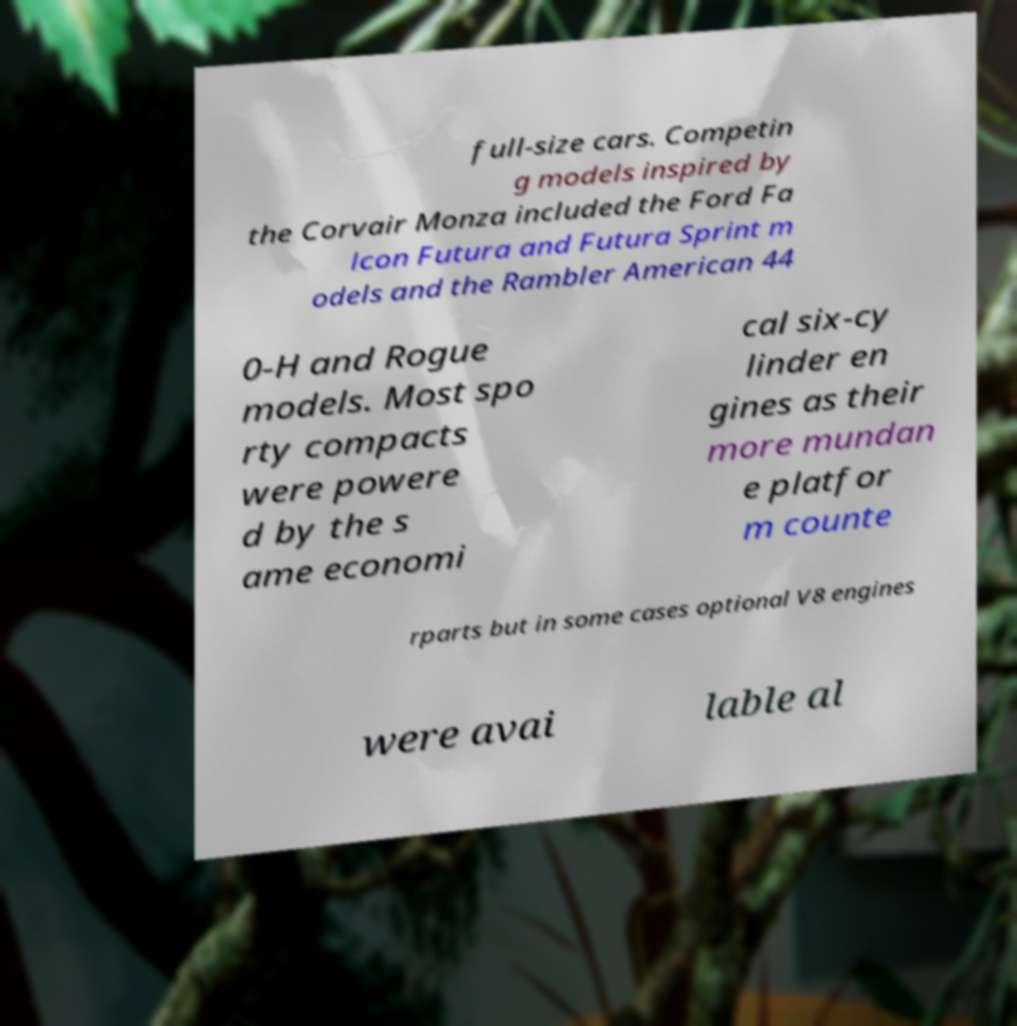There's text embedded in this image that I need extracted. Can you transcribe it verbatim? full-size cars. Competin g models inspired by the Corvair Monza included the Ford Fa lcon Futura and Futura Sprint m odels and the Rambler American 44 0-H and Rogue models. Most spo rty compacts were powere d by the s ame economi cal six-cy linder en gines as their more mundan e platfor m counte rparts but in some cases optional V8 engines were avai lable al 